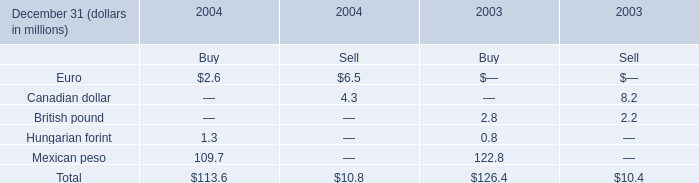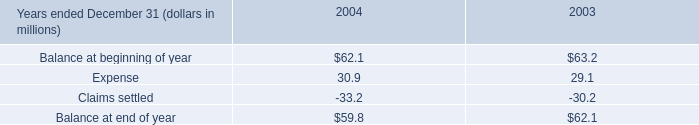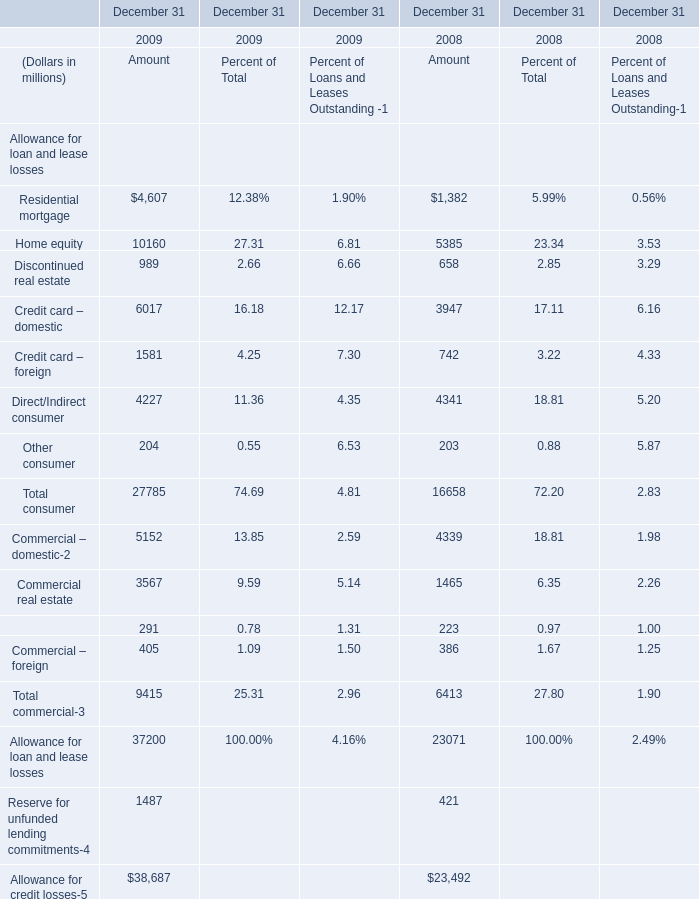What's the average of the Mexican peso for Buy in the years where Expense is positive? (in million) 
Computations: ((109.7 + 122.8) / 2)
Answer: 116.25. 